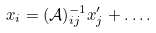<formula> <loc_0><loc_0><loc_500><loc_500>x _ { i } = ( \mathcal { A } ) ^ { - 1 } _ { i j } x ^ { \prime } _ { j } + \dots .</formula> 